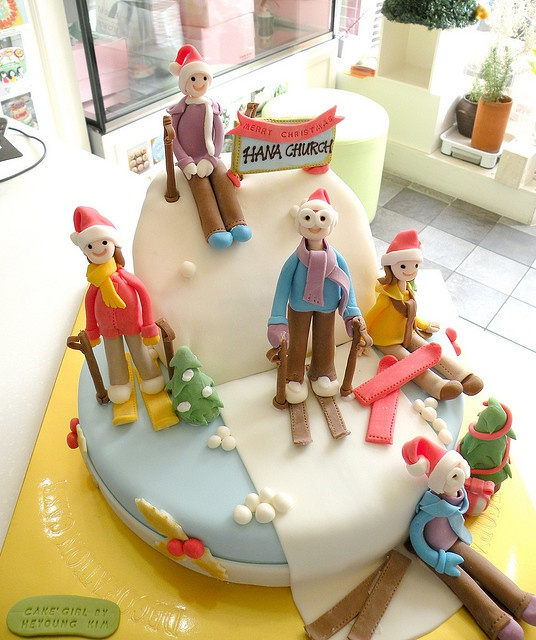Describe the objects in this image and their specific colors. I can see cake in khaki, ivory, darkgray, and tan tones, potted plant in khaki, tan, white, black, and darkgreen tones, skis in khaki, maroon, olive, and gray tones, potted plant in khaki, red, ivory, beige, and olive tones, and skis in khaki, salmon, and red tones in this image. 